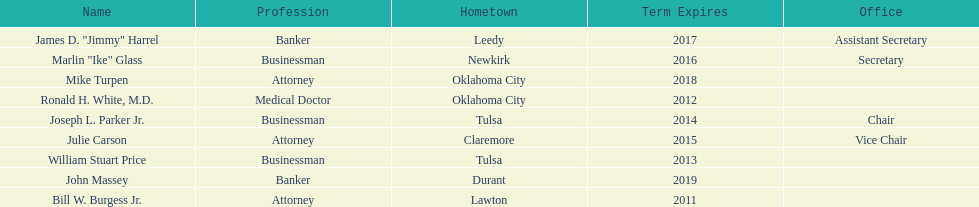Would you be able to parse every entry in this table? {'header': ['Name', 'Profession', 'Hometown', 'Term Expires', 'Office'], 'rows': [['James D. "Jimmy" Harrel', 'Banker', 'Leedy', '2017', 'Assistant Secretary'], ['Marlin "Ike" Glass', 'Businessman', 'Newkirk', '2016', 'Secretary'], ['Mike Turpen', 'Attorney', 'Oklahoma City', '2018', ''], ['Ronald H. White, M.D.', 'Medical Doctor', 'Oklahoma City', '2012', ''], ['Joseph L. Parker Jr.', 'Businessman', 'Tulsa', '2014', 'Chair'], ['Julie Carson', 'Attorney', 'Claremore', '2015', 'Vice Chair'], ['William Stuart Price', 'Businessman', 'Tulsa', '2013', ''], ['John Massey', 'Banker', 'Durant', '2019', ''], ['Bill W. Burgess Jr.', 'Attorney', 'Lawton', '2011', '']]} Which state regent is from the same hometown as ronald h. white, m.d.? Mike Turpen. 